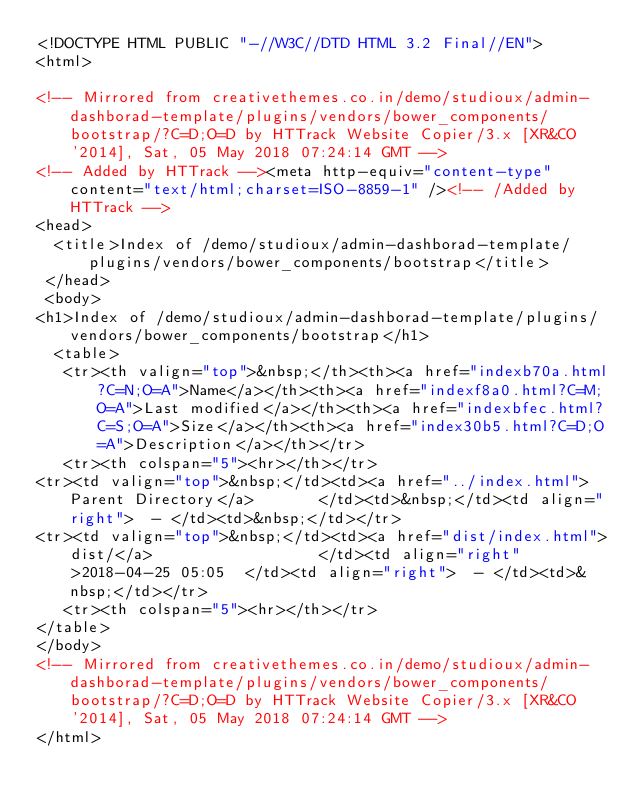<code> <loc_0><loc_0><loc_500><loc_500><_HTML_><!DOCTYPE HTML PUBLIC "-//W3C//DTD HTML 3.2 Final//EN">
<html>
 
<!-- Mirrored from creativethemes.co.in/demo/studioux/admin-dashborad-template/plugins/vendors/bower_components/bootstrap/?C=D;O=D by HTTrack Website Copier/3.x [XR&CO'2014], Sat, 05 May 2018 07:24:14 GMT -->
<!-- Added by HTTrack --><meta http-equiv="content-type" content="text/html;charset=ISO-8859-1" /><!-- /Added by HTTrack -->
<head>
  <title>Index of /demo/studioux/admin-dashborad-template/plugins/vendors/bower_components/bootstrap</title>
 </head>
 <body>
<h1>Index of /demo/studioux/admin-dashborad-template/plugins/vendors/bower_components/bootstrap</h1>
  <table>
   <tr><th valign="top">&nbsp;</th><th><a href="indexb70a.html?C=N;O=A">Name</a></th><th><a href="indexf8a0.html?C=M;O=A">Last modified</a></th><th><a href="indexbfec.html?C=S;O=A">Size</a></th><th><a href="index30b5.html?C=D;O=A">Description</a></th></tr>
   <tr><th colspan="5"><hr></th></tr>
<tr><td valign="top">&nbsp;</td><td><a href="../index.html">Parent Directory</a>       </td><td>&nbsp;</td><td align="right">  - </td><td>&nbsp;</td></tr>
<tr><td valign="top">&nbsp;</td><td><a href="dist/index.html">dist/</a>                  </td><td align="right">2018-04-25 05:05  </td><td align="right">  - </td><td>&nbsp;</td></tr>
   <tr><th colspan="5"><hr></th></tr>
</table>
</body>
<!-- Mirrored from creativethemes.co.in/demo/studioux/admin-dashborad-template/plugins/vendors/bower_components/bootstrap/?C=D;O=D by HTTrack Website Copier/3.x [XR&CO'2014], Sat, 05 May 2018 07:24:14 GMT -->
</html>
</code> 